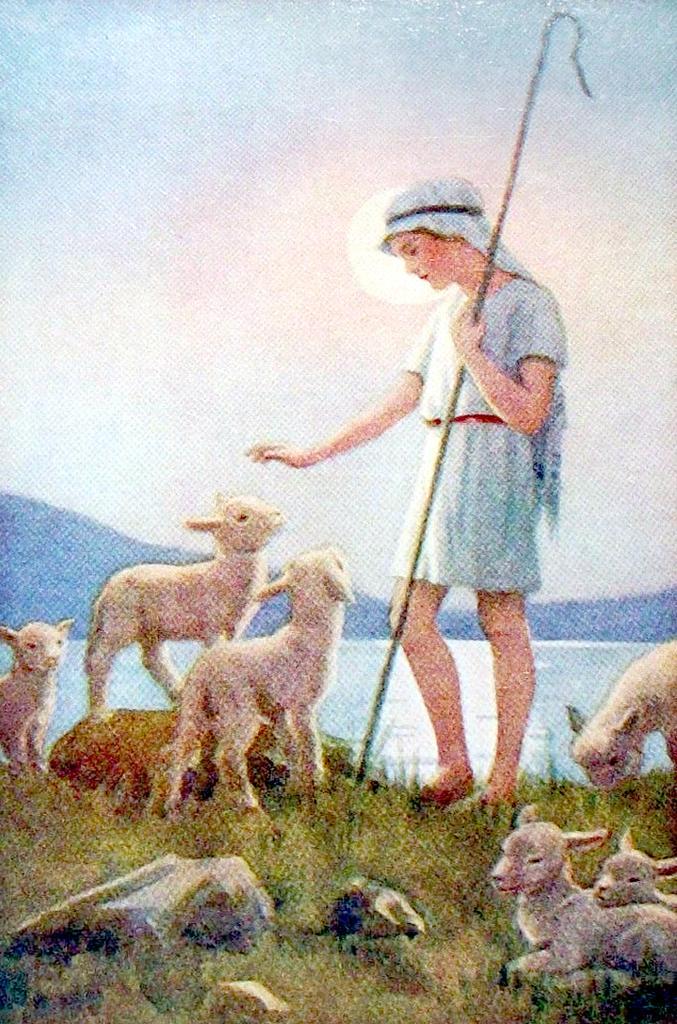How would you summarize this image in a sentence or two? This is a picture and here we can see a person wearing a cap and holding a stick. At the bottom, there are animals and rocks on the ground and there is water. In the background, there are hills and at the top, there is sun in the sky. 